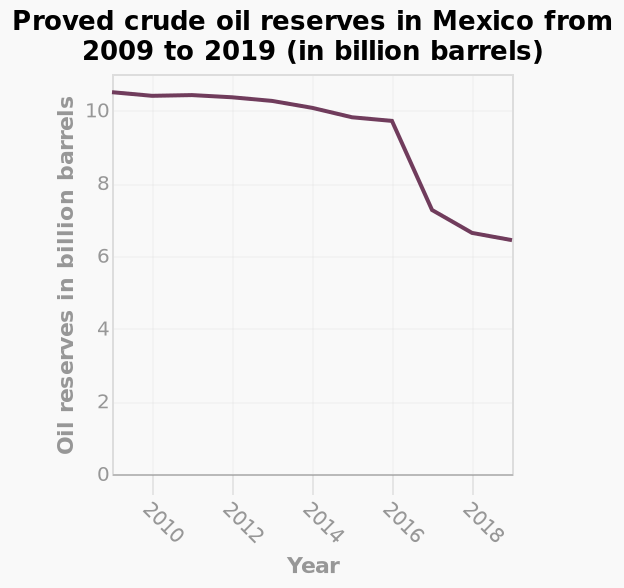<image>
What is the range of the y-axis in the line diagram? The range of the y-axis is from 0 to 10 billion barrels. What is the range of the x-axis? The range of the x-axis is from 2010 to 2018. What does the x-axis represent in the line diagram?  The x-axis represents the year from 2010 to 2018. What is the title of the line diagram?  The title of the line diagram is "Proved crude oil reserves in Mexico from 2009 to 2019 (in billion barrels)". What does the y-axis represent in the line diagram?  The y-axis represents the oil reserves in billion barrels ranging from 0 to 10. 